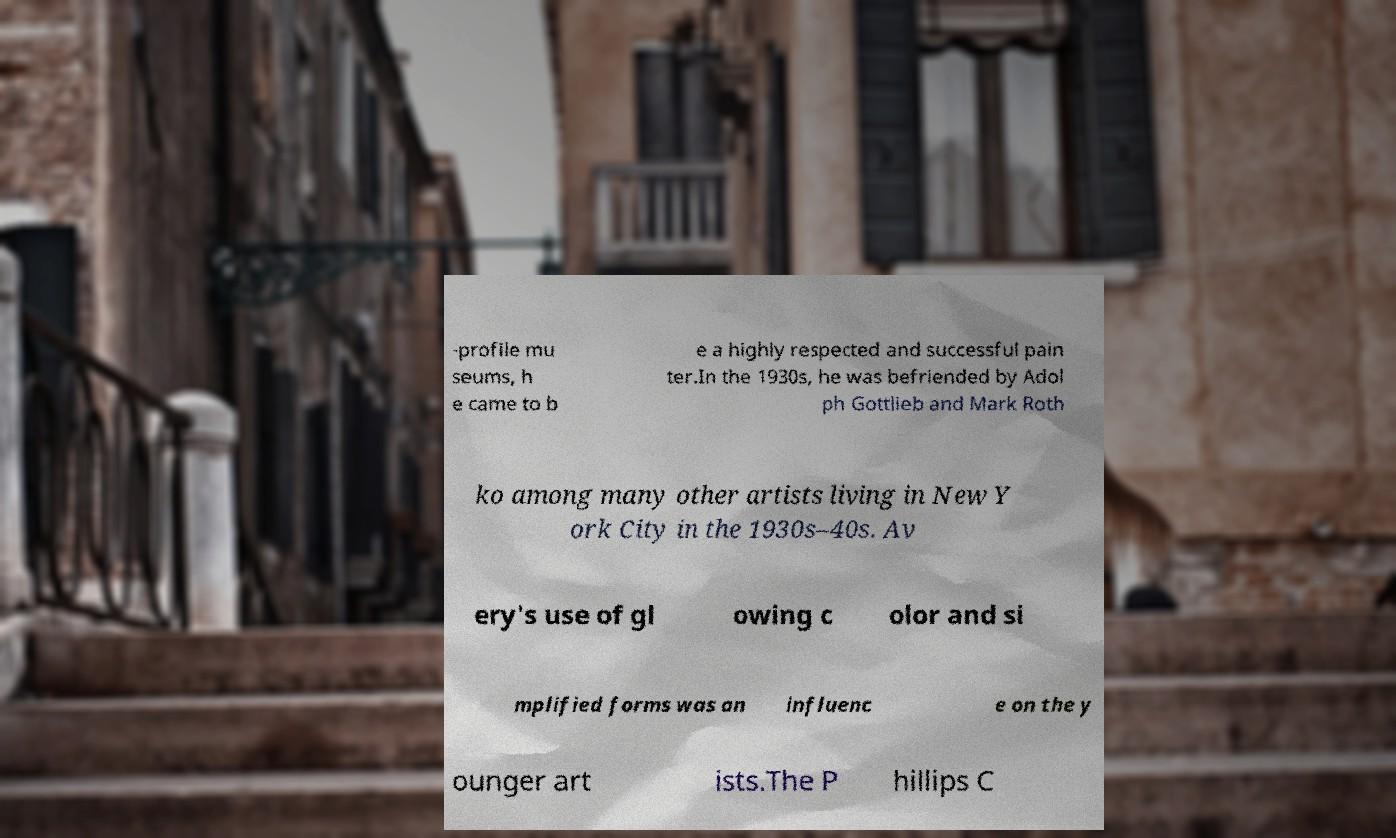Could you assist in decoding the text presented in this image and type it out clearly? -profile mu seums, h e came to b e a highly respected and successful pain ter.In the 1930s, he was befriended by Adol ph Gottlieb and Mark Roth ko among many other artists living in New Y ork City in the 1930s–40s. Av ery's use of gl owing c olor and si mplified forms was an influenc e on the y ounger art ists.The P hillips C 